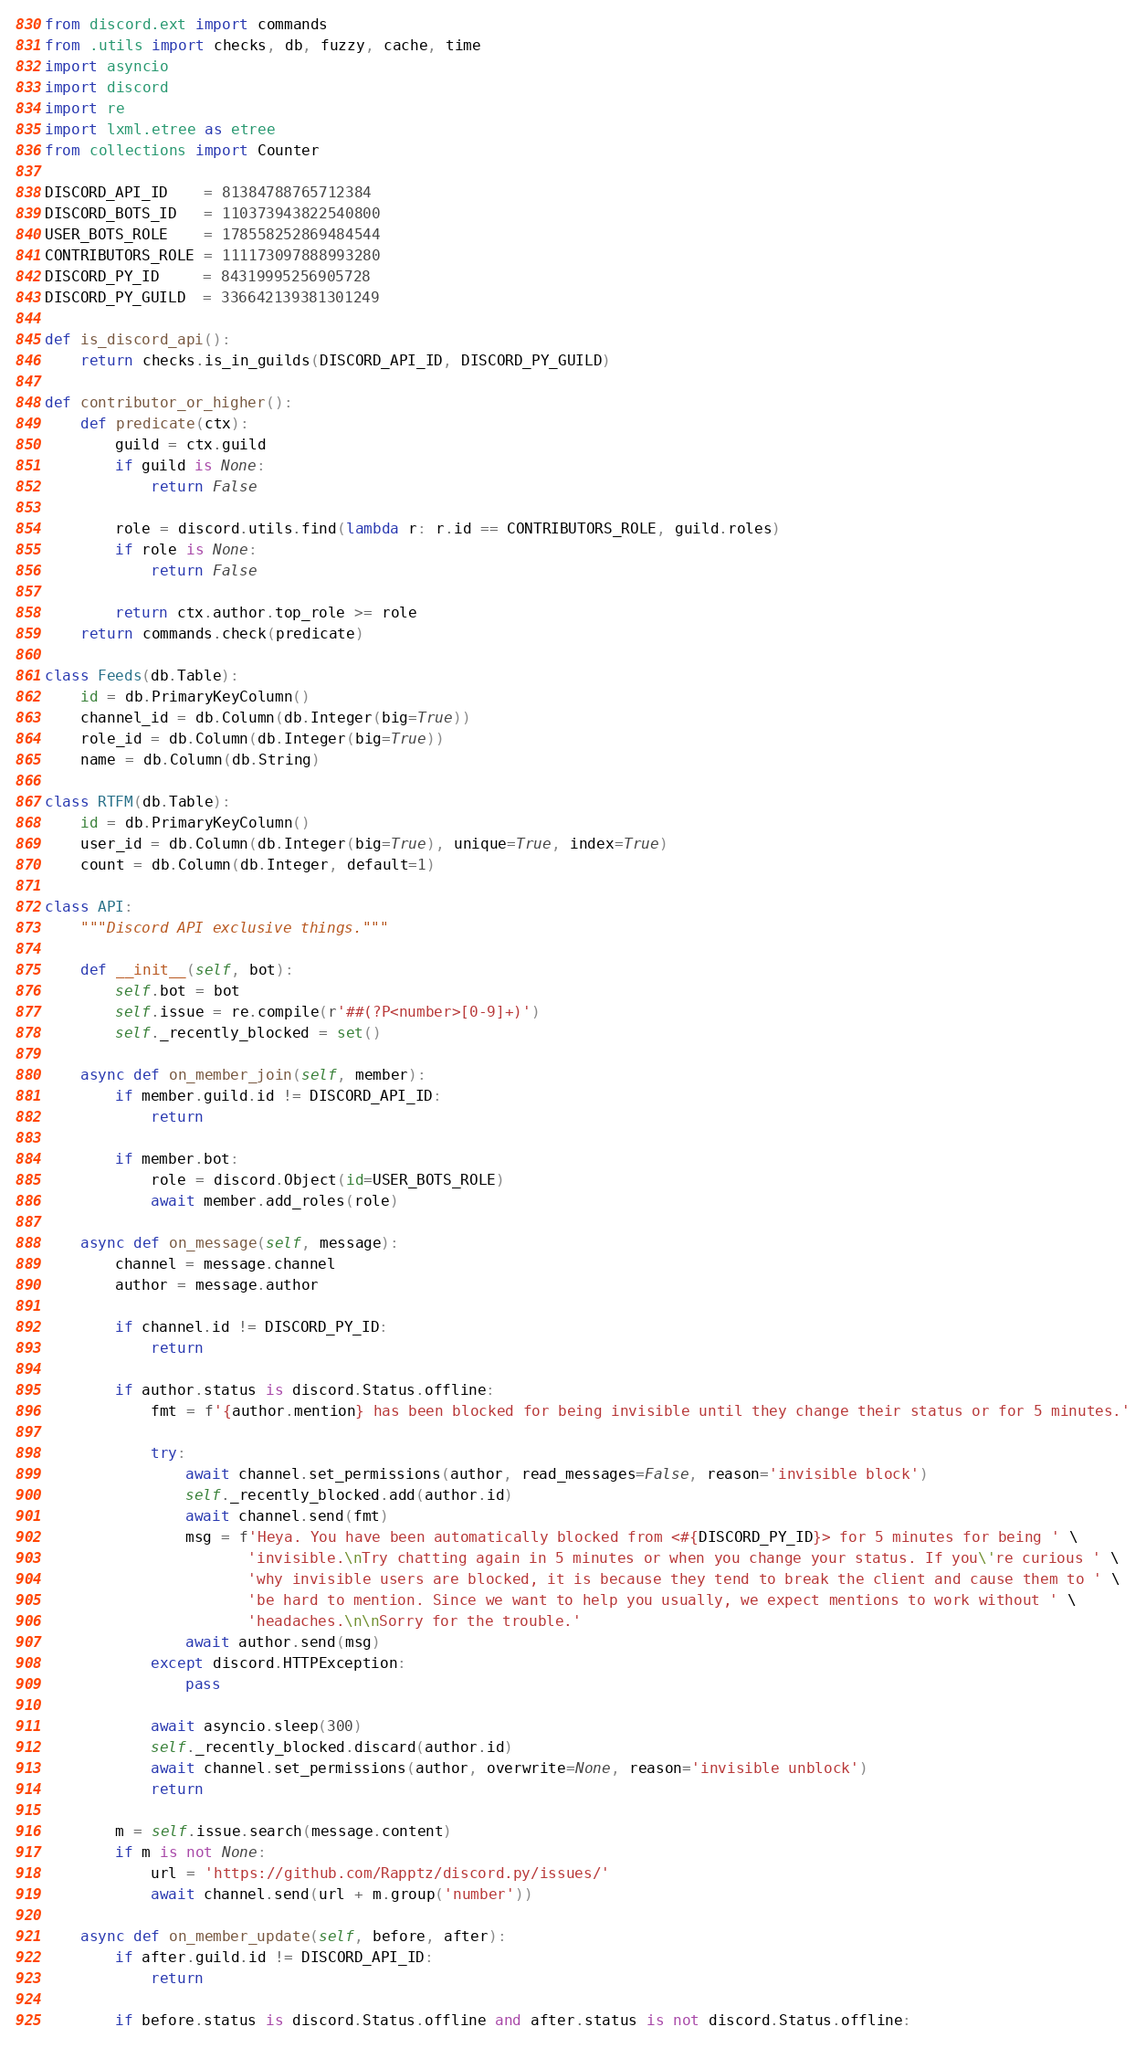Convert code to text. <code><loc_0><loc_0><loc_500><loc_500><_Python_>from discord.ext import commands
from .utils import checks, db, fuzzy, cache, time
import asyncio
import discord
import re
import lxml.etree as etree
from collections import Counter

DISCORD_API_ID    = 81384788765712384
DISCORD_BOTS_ID   = 110373943822540800
USER_BOTS_ROLE    = 178558252869484544
CONTRIBUTORS_ROLE = 111173097888993280
DISCORD_PY_ID     = 84319995256905728
DISCORD_PY_GUILD  = 336642139381301249

def is_discord_api():
    return checks.is_in_guilds(DISCORD_API_ID, DISCORD_PY_GUILD)

def contributor_or_higher():
    def predicate(ctx):
        guild = ctx.guild
        if guild is None:
            return False

        role = discord.utils.find(lambda r: r.id == CONTRIBUTORS_ROLE, guild.roles)
        if role is None:
            return False

        return ctx.author.top_role >= role
    return commands.check(predicate)

class Feeds(db.Table):
    id = db.PrimaryKeyColumn()
    channel_id = db.Column(db.Integer(big=True))
    role_id = db.Column(db.Integer(big=True))
    name = db.Column(db.String)

class RTFM(db.Table):
    id = db.PrimaryKeyColumn()
    user_id = db.Column(db.Integer(big=True), unique=True, index=True)
    count = db.Column(db.Integer, default=1)

class API:
    """Discord API exclusive things."""

    def __init__(self, bot):
        self.bot = bot
        self.issue = re.compile(r'##(?P<number>[0-9]+)')
        self._recently_blocked = set()

    async def on_member_join(self, member):
        if member.guild.id != DISCORD_API_ID:
            return

        if member.bot:
            role = discord.Object(id=USER_BOTS_ROLE)
            await member.add_roles(role)

    async def on_message(self, message):
        channel = message.channel
        author = message.author

        if channel.id != DISCORD_PY_ID:
            return

        if author.status is discord.Status.offline:
            fmt = f'{author.mention} has been blocked for being invisible until they change their status or for 5 minutes.'

            try:
                await channel.set_permissions(author, read_messages=False, reason='invisible block')
                self._recently_blocked.add(author.id)
                await channel.send(fmt)
                msg = f'Heya. You have been automatically blocked from <#{DISCORD_PY_ID}> for 5 minutes for being ' \
                       'invisible.\nTry chatting again in 5 minutes or when you change your status. If you\'re curious ' \
                       'why invisible users are blocked, it is because they tend to break the client and cause them to ' \
                       'be hard to mention. Since we want to help you usually, we expect mentions to work without ' \
                       'headaches.\n\nSorry for the trouble.'
                await author.send(msg)
            except discord.HTTPException:
                pass

            await asyncio.sleep(300)
            self._recently_blocked.discard(author.id)
            await channel.set_permissions(author, overwrite=None, reason='invisible unblock')
            return

        m = self.issue.search(message.content)
        if m is not None:
            url = 'https://github.com/Rapptz/discord.py/issues/'
            await channel.send(url + m.group('number'))

    async def on_member_update(self, before, after):
        if after.guild.id != DISCORD_API_ID:
            return

        if before.status is discord.Status.offline and after.status is not discord.Status.offline:</code> 